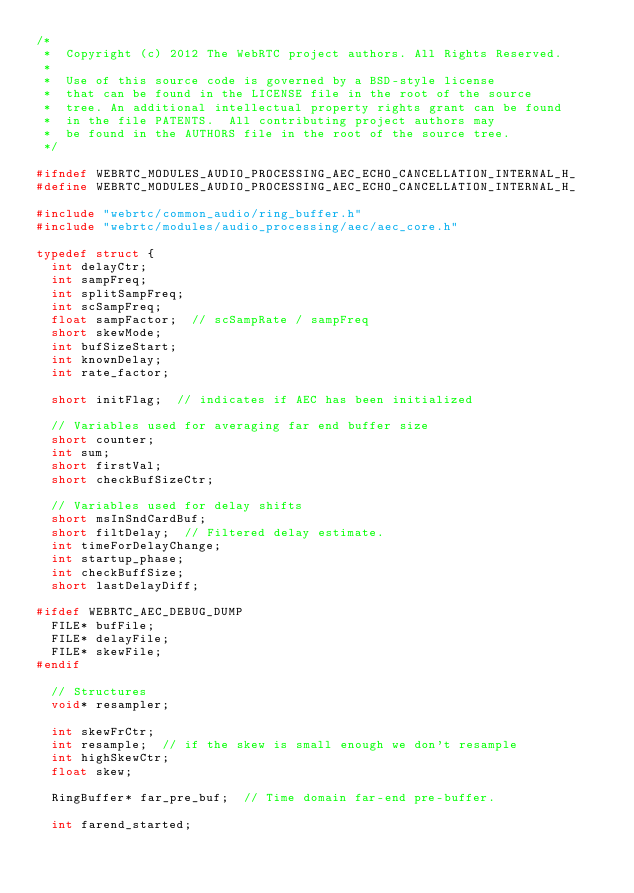<code> <loc_0><loc_0><loc_500><loc_500><_C_>/*
 *  Copyright (c) 2012 The WebRTC project authors. All Rights Reserved.
 *
 *  Use of this source code is governed by a BSD-style license
 *  that can be found in the LICENSE file in the root of the source
 *  tree. An additional intellectual property rights grant can be found
 *  in the file PATENTS.  All contributing project authors may
 *  be found in the AUTHORS file in the root of the source tree.
 */

#ifndef WEBRTC_MODULES_AUDIO_PROCESSING_AEC_ECHO_CANCELLATION_INTERNAL_H_
#define WEBRTC_MODULES_AUDIO_PROCESSING_AEC_ECHO_CANCELLATION_INTERNAL_H_

#include "webrtc/common_audio/ring_buffer.h"
#include "webrtc/modules/audio_processing/aec/aec_core.h"

typedef struct {
  int delayCtr;
  int sampFreq;
  int splitSampFreq;
  int scSampFreq;
  float sampFactor;  // scSampRate / sampFreq
  short skewMode;
  int bufSizeStart;
  int knownDelay;
  int rate_factor;

  short initFlag;  // indicates if AEC has been initialized

  // Variables used for averaging far end buffer size
  short counter;
  int sum;
  short firstVal;
  short checkBufSizeCtr;

  // Variables used for delay shifts
  short msInSndCardBuf;
  short filtDelay;  // Filtered delay estimate.
  int timeForDelayChange;
  int startup_phase;
  int checkBuffSize;
  short lastDelayDiff;

#ifdef WEBRTC_AEC_DEBUG_DUMP
  FILE* bufFile;
  FILE* delayFile;
  FILE* skewFile;
#endif

  // Structures
  void* resampler;

  int skewFrCtr;
  int resample;  // if the skew is small enough we don't resample
  int highSkewCtr;
  float skew;

  RingBuffer* far_pre_buf;  // Time domain far-end pre-buffer.

  int farend_started;
</code> 